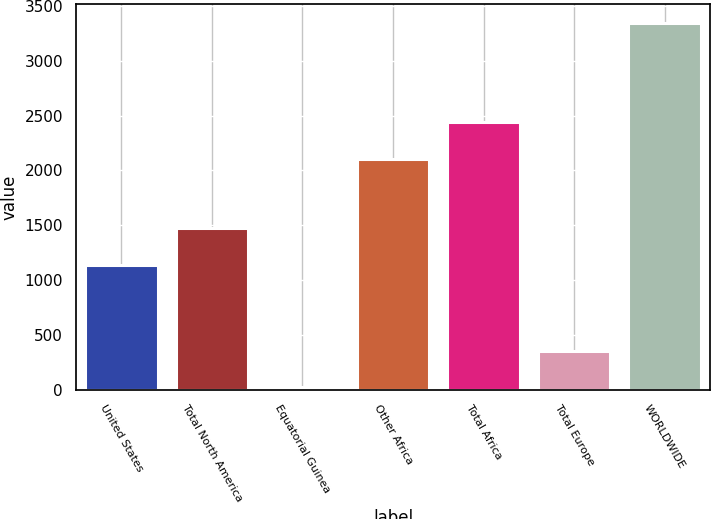Convert chart. <chart><loc_0><loc_0><loc_500><loc_500><bar_chart><fcel>United States<fcel>Total North America<fcel>Equatorial Guinea<fcel>Other Africa<fcel>Total Africa<fcel>Total Europe<fcel>WORLDWIDE<nl><fcel>1142<fcel>1473.8<fcel>29<fcel>2108<fcel>2439.8<fcel>360.8<fcel>3347<nl></chart> 